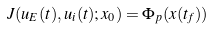Convert formula to latex. <formula><loc_0><loc_0><loc_500><loc_500>J ( u _ { E } ( t ) , u _ { i } ( t ) ; x _ { 0 } ) = \Phi _ { p } ( x ( t _ { f } ) )</formula> 